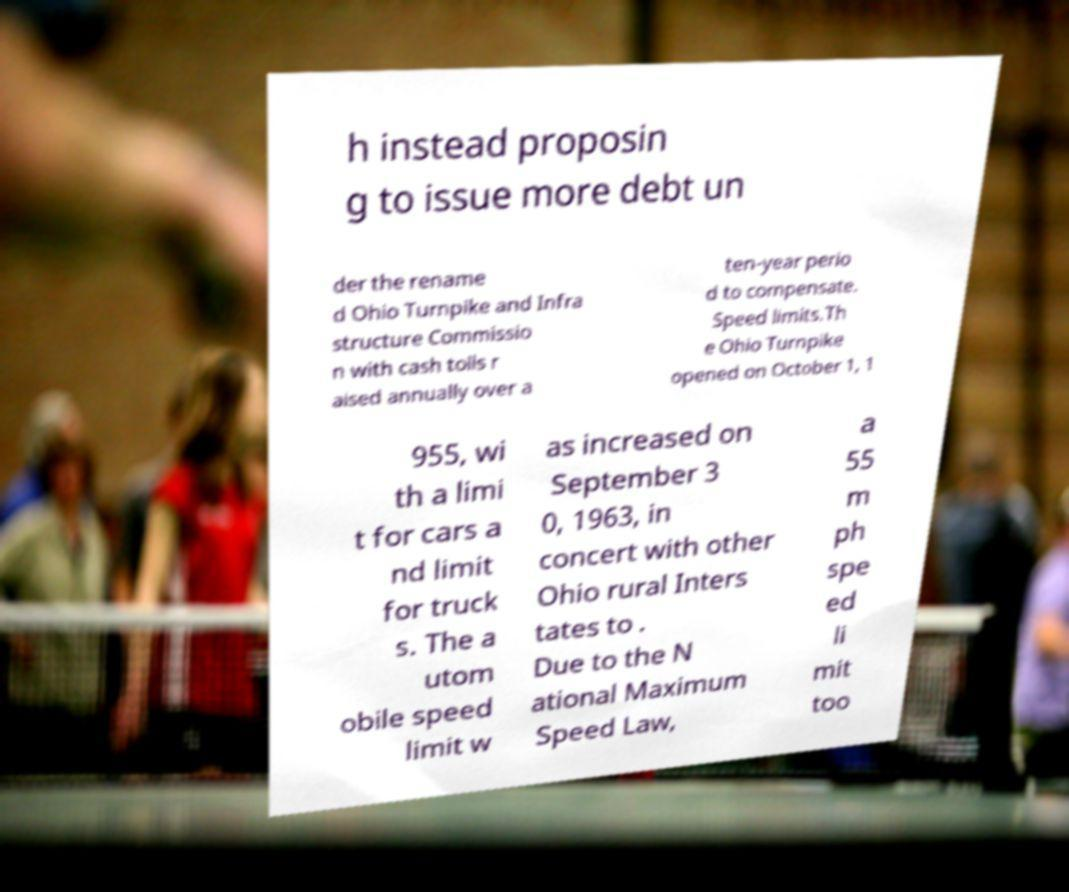Can you accurately transcribe the text from the provided image for me? h instead proposin g to issue more debt un der the rename d Ohio Turnpike and Infra structure Commissio n with cash tolls r aised annually over a ten-year perio d to compensate. Speed limits.Th e Ohio Turnpike opened on October 1, 1 955, wi th a limi t for cars a nd limit for truck s. The a utom obile speed limit w as increased on September 3 0, 1963, in concert with other Ohio rural Inters tates to . Due to the N ational Maximum Speed Law, a 55 m ph spe ed li mit too 